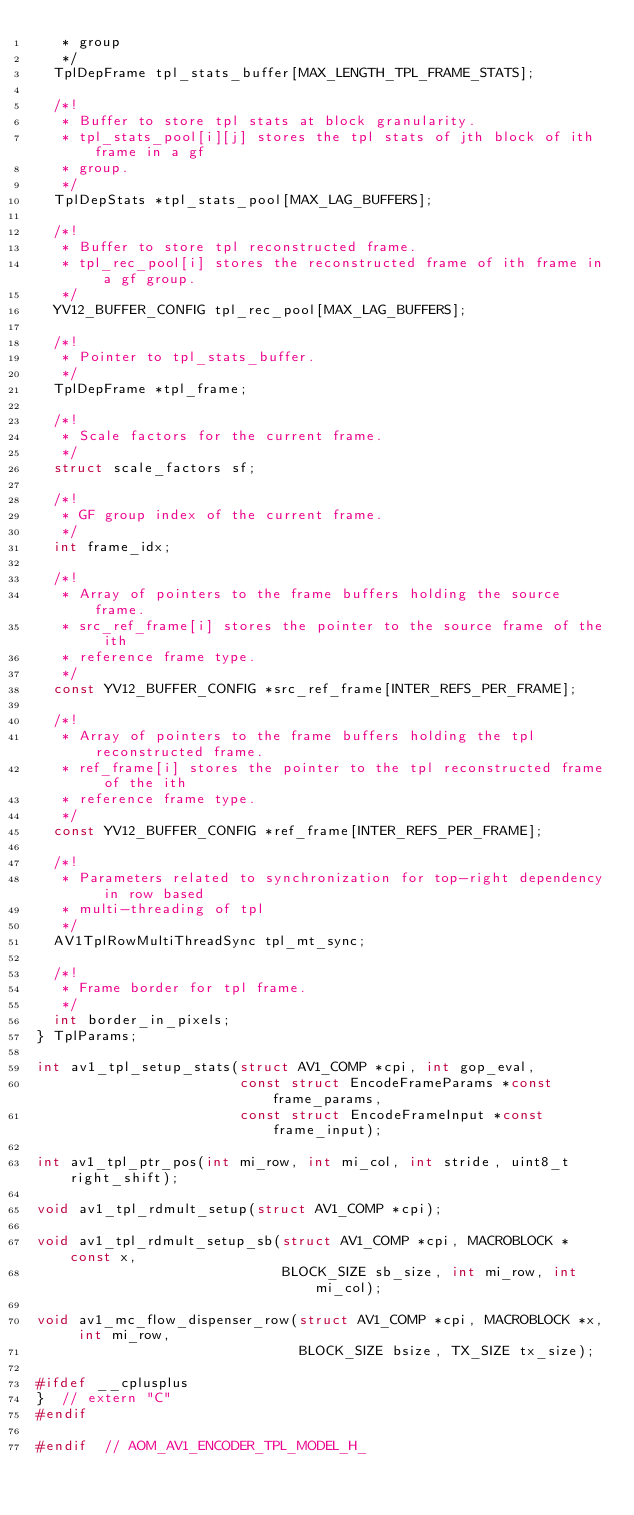Convert code to text. <code><loc_0><loc_0><loc_500><loc_500><_C_>   * group
   */
  TplDepFrame tpl_stats_buffer[MAX_LENGTH_TPL_FRAME_STATS];

  /*!
   * Buffer to store tpl stats at block granularity.
   * tpl_stats_pool[i][j] stores the tpl stats of jth block of ith frame in a gf
   * group.
   */
  TplDepStats *tpl_stats_pool[MAX_LAG_BUFFERS];

  /*!
   * Buffer to store tpl reconstructed frame.
   * tpl_rec_pool[i] stores the reconstructed frame of ith frame in a gf group.
   */
  YV12_BUFFER_CONFIG tpl_rec_pool[MAX_LAG_BUFFERS];

  /*!
   * Pointer to tpl_stats_buffer.
   */
  TplDepFrame *tpl_frame;

  /*!
   * Scale factors for the current frame.
   */
  struct scale_factors sf;

  /*!
   * GF group index of the current frame.
   */
  int frame_idx;

  /*!
   * Array of pointers to the frame buffers holding the source frame.
   * src_ref_frame[i] stores the pointer to the source frame of the ith
   * reference frame type.
   */
  const YV12_BUFFER_CONFIG *src_ref_frame[INTER_REFS_PER_FRAME];

  /*!
   * Array of pointers to the frame buffers holding the tpl reconstructed frame.
   * ref_frame[i] stores the pointer to the tpl reconstructed frame of the ith
   * reference frame type.
   */
  const YV12_BUFFER_CONFIG *ref_frame[INTER_REFS_PER_FRAME];

  /*!
   * Parameters related to synchronization for top-right dependency in row based
   * multi-threading of tpl
   */
  AV1TplRowMultiThreadSync tpl_mt_sync;

  /*!
   * Frame border for tpl frame.
   */
  int border_in_pixels;
} TplParams;

int av1_tpl_setup_stats(struct AV1_COMP *cpi, int gop_eval,
                        const struct EncodeFrameParams *const frame_params,
                        const struct EncodeFrameInput *const frame_input);

int av1_tpl_ptr_pos(int mi_row, int mi_col, int stride, uint8_t right_shift);

void av1_tpl_rdmult_setup(struct AV1_COMP *cpi);

void av1_tpl_rdmult_setup_sb(struct AV1_COMP *cpi, MACROBLOCK *const x,
                             BLOCK_SIZE sb_size, int mi_row, int mi_col);

void av1_mc_flow_dispenser_row(struct AV1_COMP *cpi, MACROBLOCK *x, int mi_row,
                               BLOCK_SIZE bsize, TX_SIZE tx_size);

#ifdef __cplusplus
}  // extern "C"
#endif

#endif  // AOM_AV1_ENCODER_TPL_MODEL_H_
</code> 